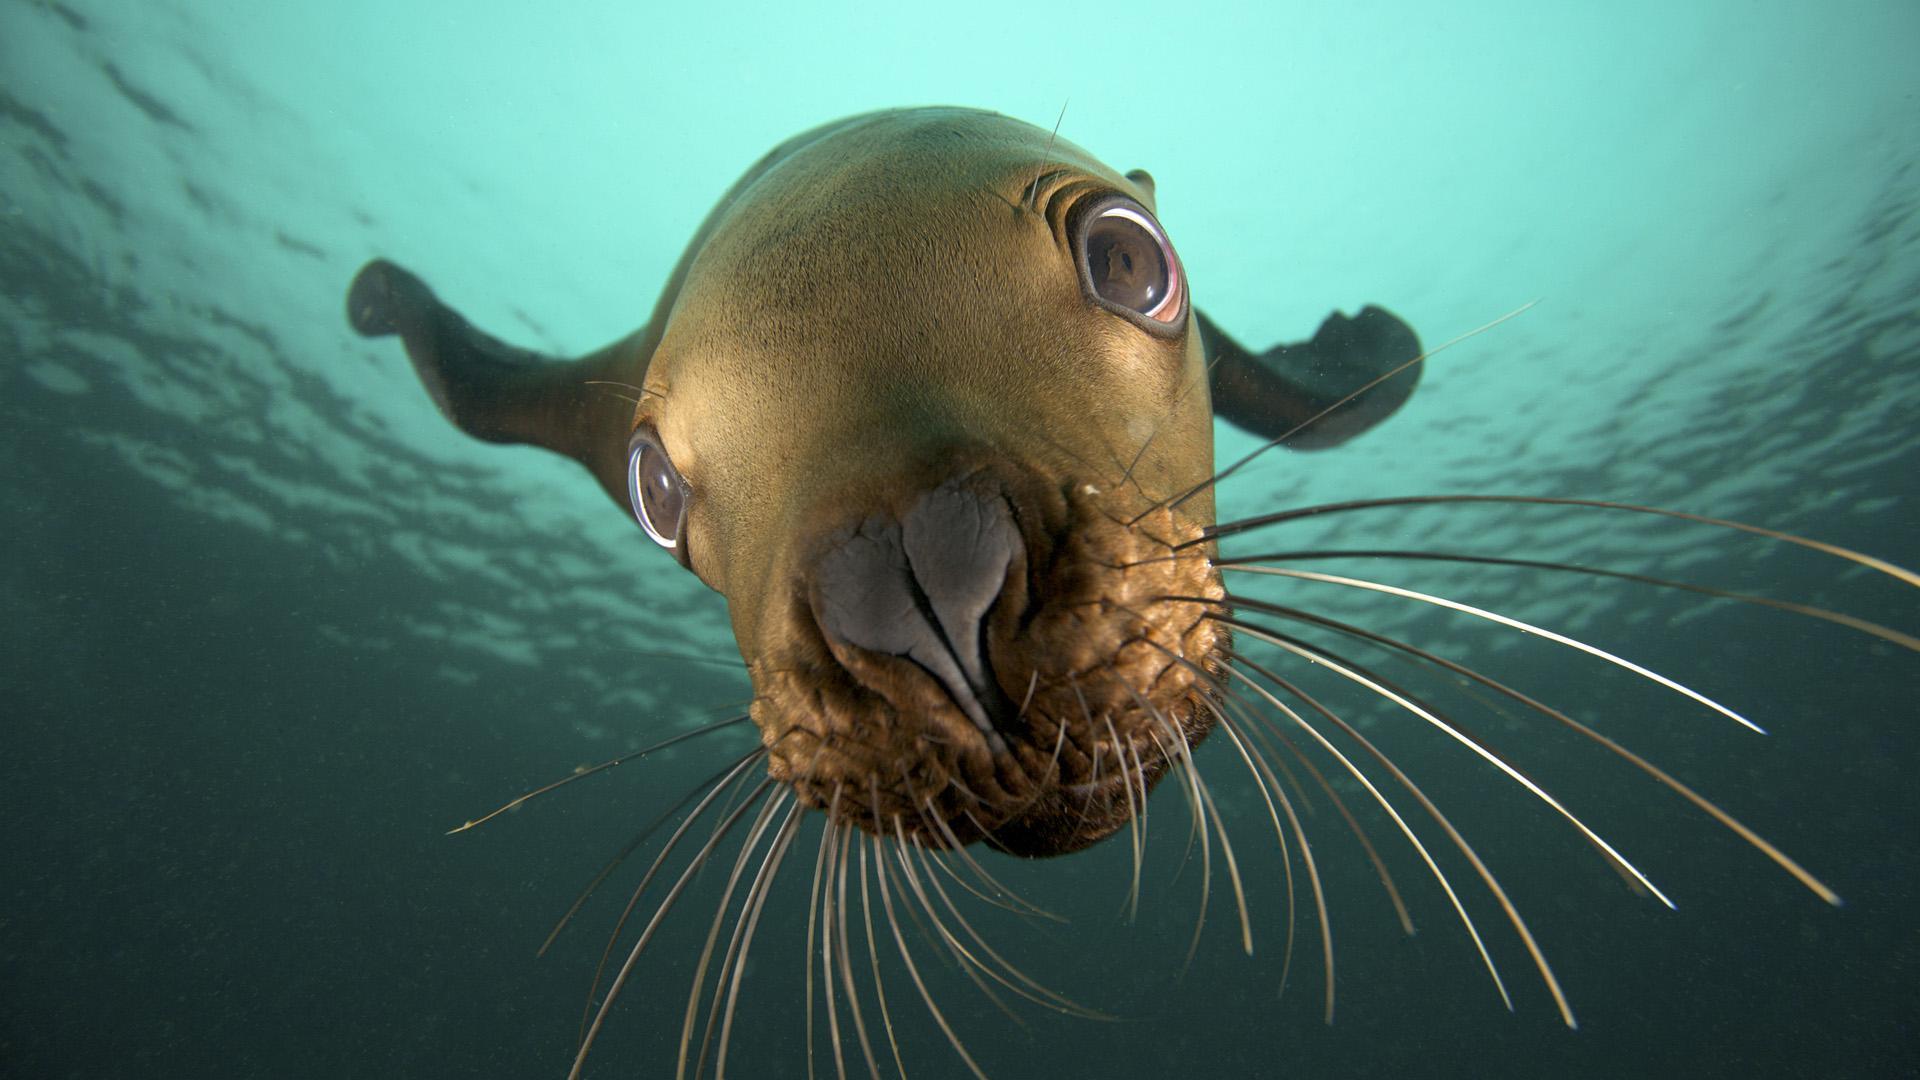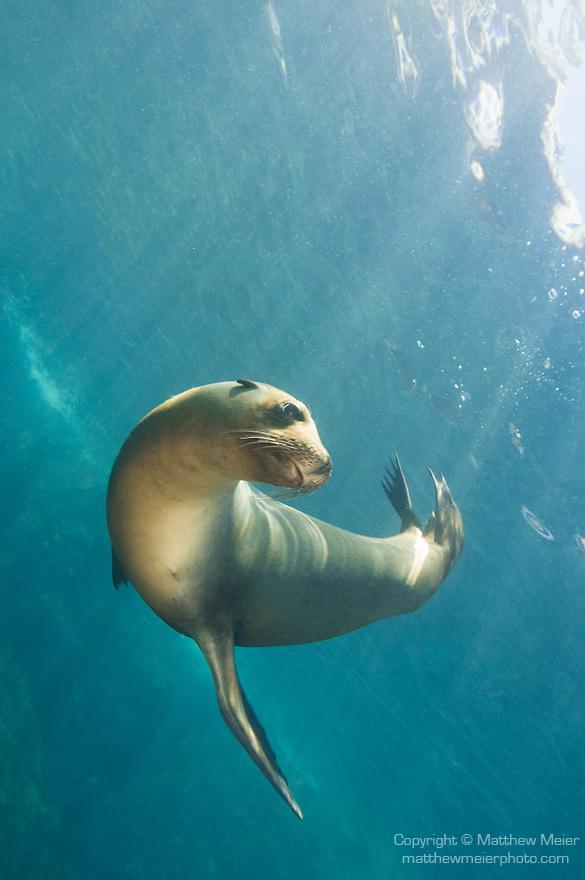The first image is the image on the left, the second image is the image on the right. Considering the images on both sides, is "In one image there are at least six sea lions." valid? Answer yes or no. No. The first image is the image on the left, the second image is the image on the right. For the images displayed, is the sentence "In the left image, there's only one seal and it's looking directly at the camera." factually correct? Answer yes or no. Yes. 